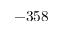Convert formula to latex. <formula><loc_0><loc_0><loc_500><loc_500>- 3 5 8</formula> 